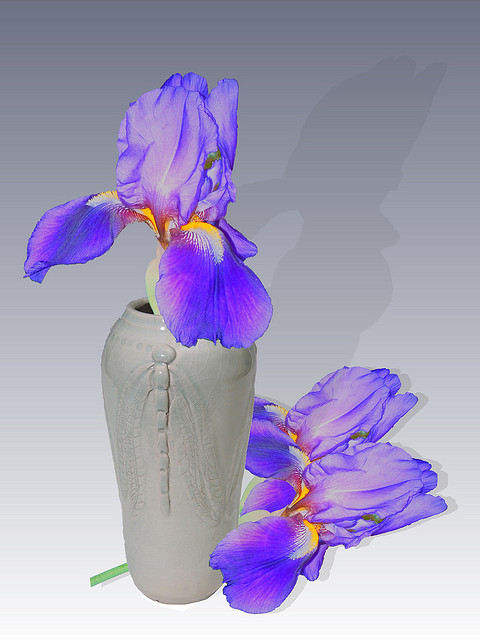<image>What animal is shown? It is unclear what animal is shown. It might be a dragonfly or there might be no animal at all. What animal is shown? I am not sure what animal is shown. It could be a dragonfly or a bug. 